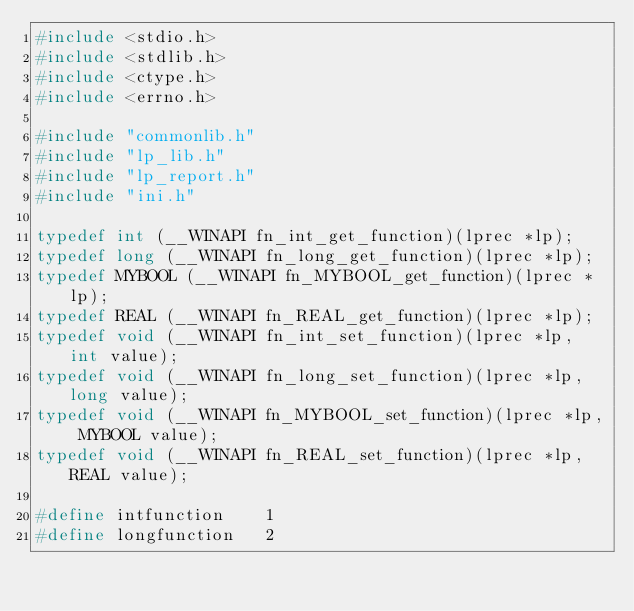Convert code to text. <code><loc_0><loc_0><loc_500><loc_500><_C_>#include <stdio.h>
#include <stdlib.h>
#include <ctype.h>
#include <errno.h>

#include "commonlib.h"
#include "lp_lib.h"
#include "lp_report.h"
#include "ini.h"

typedef int (__WINAPI fn_int_get_function)(lprec *lp);
typedef long (__WINAPI fn_long_get_function)(lprec *lp);
typedef MYBOOL (__WINAPI fn_MYBOOL_get_function)(lprec *lp);
typedef REAL (__WINAPI fn_REAL_get_function)(lprec *lp);
typedef void (__WINAPI fn_int_set_function)(lprec *lp, int value);
typedef void (__WINAPI fn_long_set_function)(lprec *lp, long value);
typedef void (__WINAPI fn_MYBOOL_set_function)(lprec *lp, MYBOOL value);
typedef void (__WINAPI fn_REAL_set_function)(lprec *lp, REAL value);

#define intfunction    1
#define longfunction   2</code> 